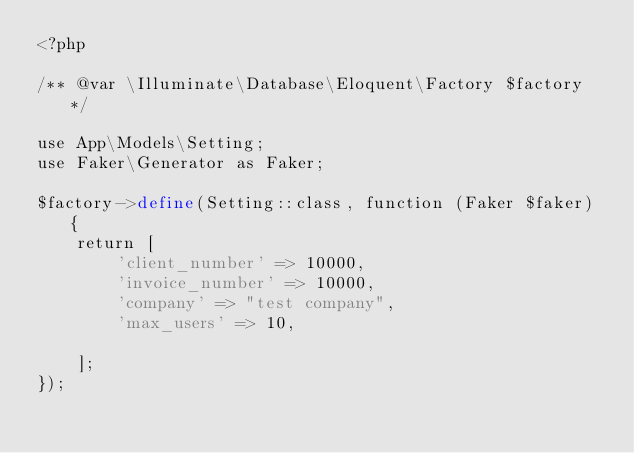<code> <loc_0><loc_0><loc_500><loc_500><_PHP_><?php

/** @var \Illuminate\Database\Eloquent\Factory $factory */

use App\Models\Setting;
use Faker\Generator as Faker;

$factory->define(Setting::class, function (Faker $faker) {
    return [
        'client_number' => 10000,
        'invoice_number' => 10000,
        'company' => "test company",
        'max_users' => 10,

    ];
});
</code> 